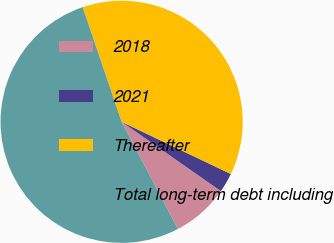Convert chart. <chart><loc_0><loc_0><loc_500><loc_500><pie_chart><fcel>2018<fcel>2021<fcel>Thereafter<fcel>Total long-term debt including<nl><fcel>7.6%<fcel>2.61%<fcel>37.31%<fcel>52.49%<nl></chart> 